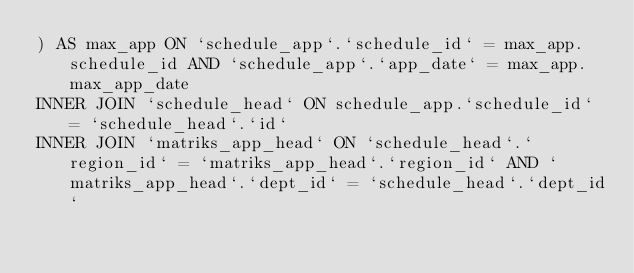<code> <loc_0><loc_0><loc_500><loc_500><_SQL_>) AS max_app ON `schedule_app`.`schedule_id` = max_app.schedule_id AND `schedule_app`.`app_date` = max_app.max_app_date
INNER JOIN `schedule_head` ON schedule_app.`schedule_id` = `schedule_head`.`id`
INNER JOIN `matriks_app_head` ON `schedule_head`.`region_id` = `matriks_app_head`.`region_id` AND `matriks_app_head`.`dept_id` = `schedule_head`.`dept_id`</code> 